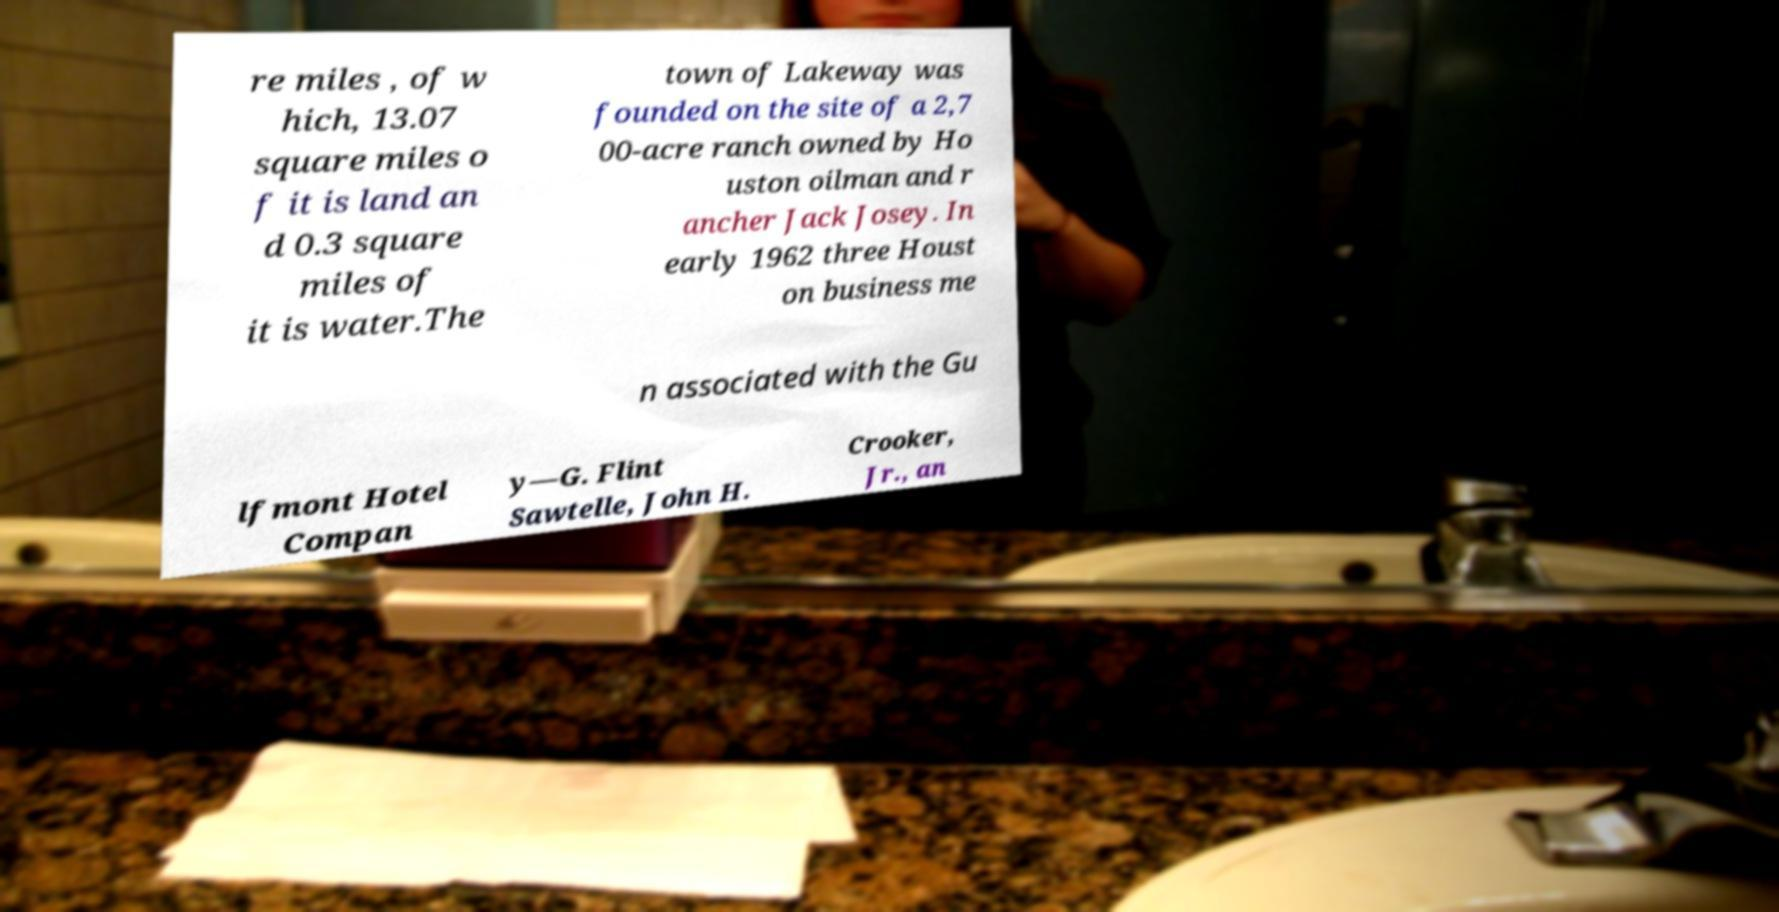I need the written content from this picture converted into text. Can you do that? re miles , of w hich, 13.07 square miles o f it is land an d 0.3 square miles of it is water.The town of Lakeway was founded on the site of a 2,7 00-acre ranch owned by Ho uston oilman and r ancher Jack Josey. In early 1962 three Houst on business me n associated with the Gu lfmont Hotel Compan y—G. Flint Sawtelle, John H. Crooker, Jr., an 